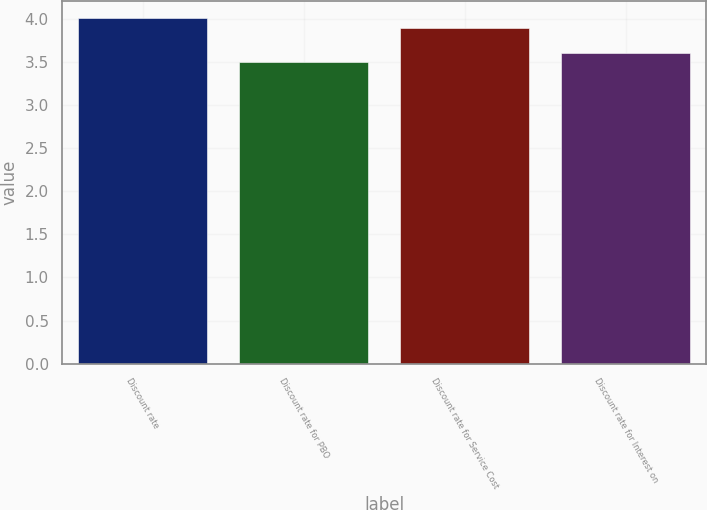Convert chart to OTSL. <chart><loc_0><loc_0><loc_500><loc_500><bar_chart><fcel>Discount rate<fcel>Discount rate for PBO<fcel>Discount rate for Service Cost<fcel>Discount rate for Interest on<nl><fcel>4.01<fcel>3.5<fcel>3.9<fcel>3.61<nl></chart> 